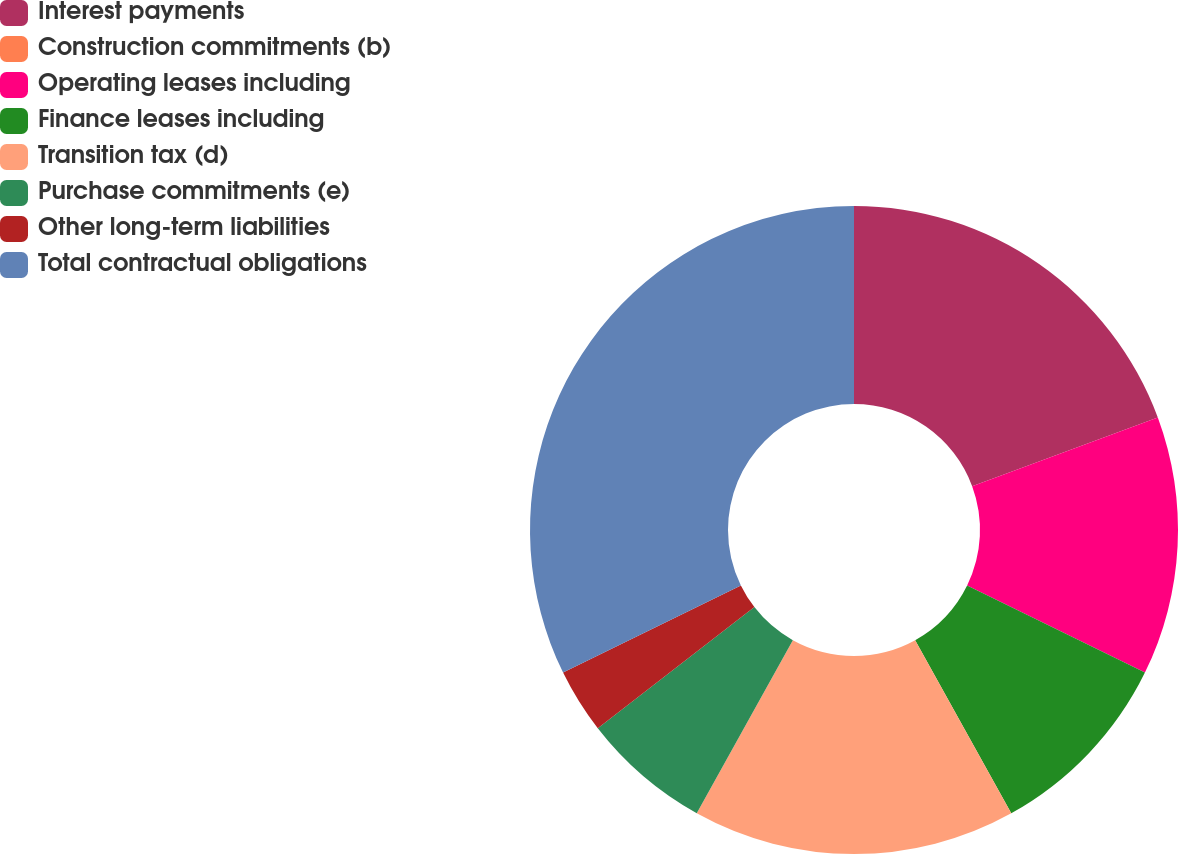<chart> <loc_0><loc_0><loc_500><loc_500><pie_chart><fcel>Interest payments<fcel>Construction commitments (b)<fcel>Operating leases including<fcel>Finance leases including<fcel>Transition tax (d)<fcel>Purchase commitments (e)<fcel>Other long-term liabilities<fcel>Total contractual obligations<nl><fcel>19.35%<fcel>0.0%<fcel>12.9%<fcel>9.68%<fcel>16.13%<fcel>6.45%<fcel>3.23%<fcel>32.25%<nl></chart> 